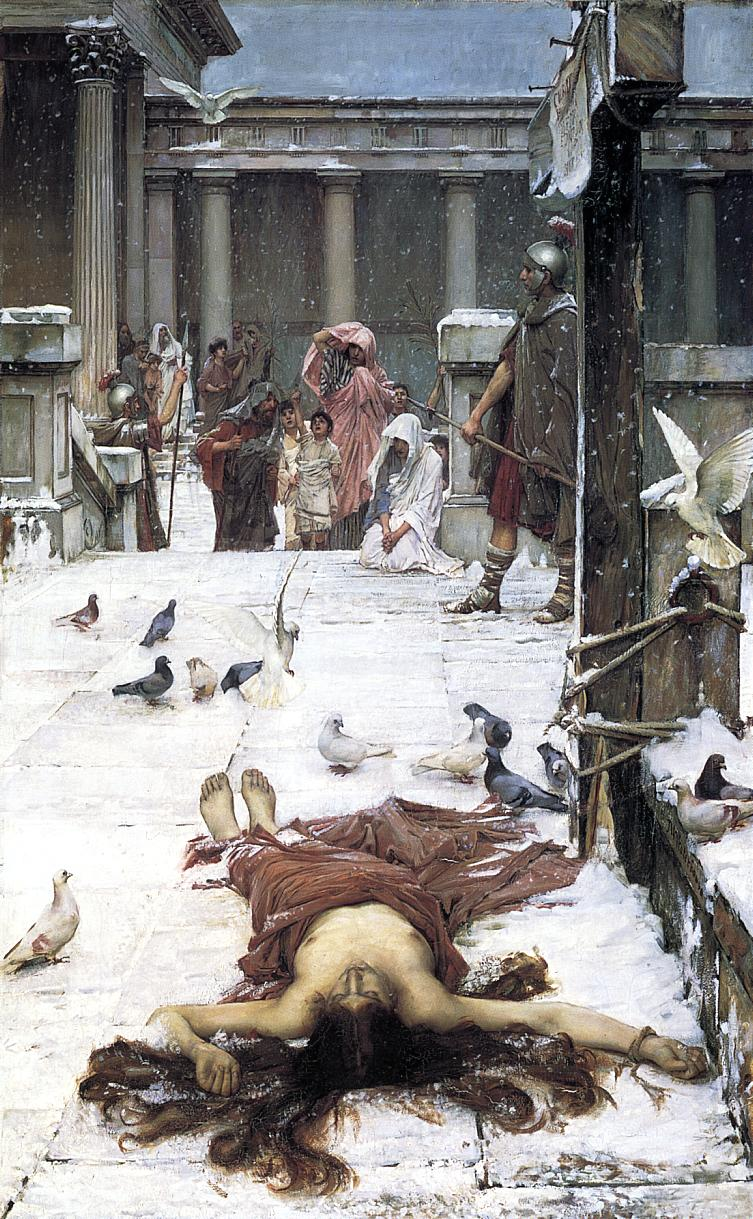What do you see happening in this image? The painting portrays a poignant and possibly tragic scene set in a historical Roman setting, suggested by the architectural columns and classical attire of the figures. Center stage, a woman lies sprawled on snowy steps, her body and face expressing despair or exhaustion, perhaps indicating a downfall or demise. Surrounding her, a diverse group of people, including robed women, children, and armored guards, react with various degrees of concern and curiosity. This juxtaposition of cold, snowy environment against the warmth of human emotions evokes a strong narrative of contrast and drama. Pigeons, fluttering about and settled on the snow, add a touch of lively movement, contrasting with the stillness of the central figure. This artwork could be exploring themes of social hierarchy, human fragility, or the randomness of fate, inviting viewers to reflect on the story leading up to this moment and its implications on the figures involved. 